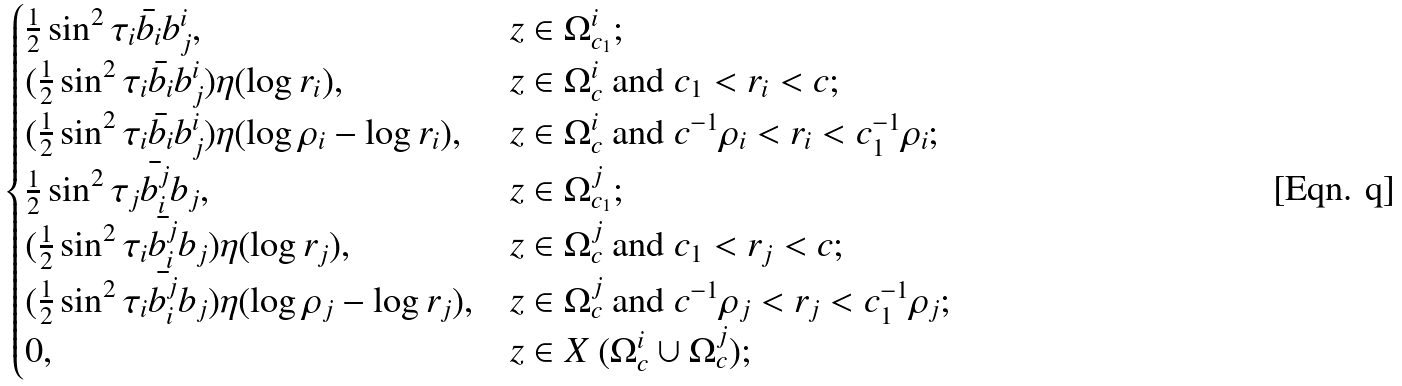<formula> <loc_0><loc_0><loc_500><loc_500>\begin{cases} \frac { 1 } { 2 } \sin ^ { 2 } \tau _ { i } \bar { b _ { i } } b _ { j } ^ { i } , & z \in \Omega _ { c _ { 1 } } ^ { i } ; \\ ( \frac { 1 } { 2 } \sin ^ { 2 } \tau _ { i } \bar { b _ { i } } b _ { j } ^ { i } ) \eta ( \log r _ { i } ) , & z \in \Omega _ { c } ^ { i } \text { and } c _ { 1 } < r _ { i } < c ; \\ ( \frac { 1 } { 2 } \sin ^ { 2 } \tau _ { i } \bar { b _ { i } } b _ { j } ^ { i } ) \eta ( \log \rho _ { i } - \log r _ { i } ) , & z \in \Omega _ { c } ^ { i } \text { and } c ^ { - 1 } \rho _ { i } < r _ { i } < c _ { 1 } ^ { - 1 } \rho _ { i } ; \\ \frac { 1 } { 2 } \sin ^ { 2 } \tau _ { j } \bar { b _ { i } ^ { j } } b _ { j } , & z \in \Omega _ { c _ { 1 } } ^ { j } ; \\ ( \frac { 1 } { 2 } \sin ^ { 2 } \tau _ { i } \bar { b _ { i } ^ { j } } b _ { j } ) \eta ( \log r _ { j } ) , & z \in \Omega _ { c } ^ { j } \text { and } c _ { 1 } < r _ { j } < c ; \\ ( \frac { 1 } { 2 } \sin ^ { 2 } \tau _ { i } \bar { b _ { i } ^ { j } } b _ { j } ) \eta ( \log \rho _ { j } - \log r _ { j } ) , & z \in \Omega _ { c } ^ { j } \text { and } c ^ { - 1 } \rho _ { j } < r _ { j } < c _ { 1 } ^ { - 1 } \rho _ { j } ; \\ 0 , & z \in X \ ( \Omega _ { c } ^ { i } \cup \Omega _ { c } ^ { j } ) ; \\ \end{cases}</formula> 